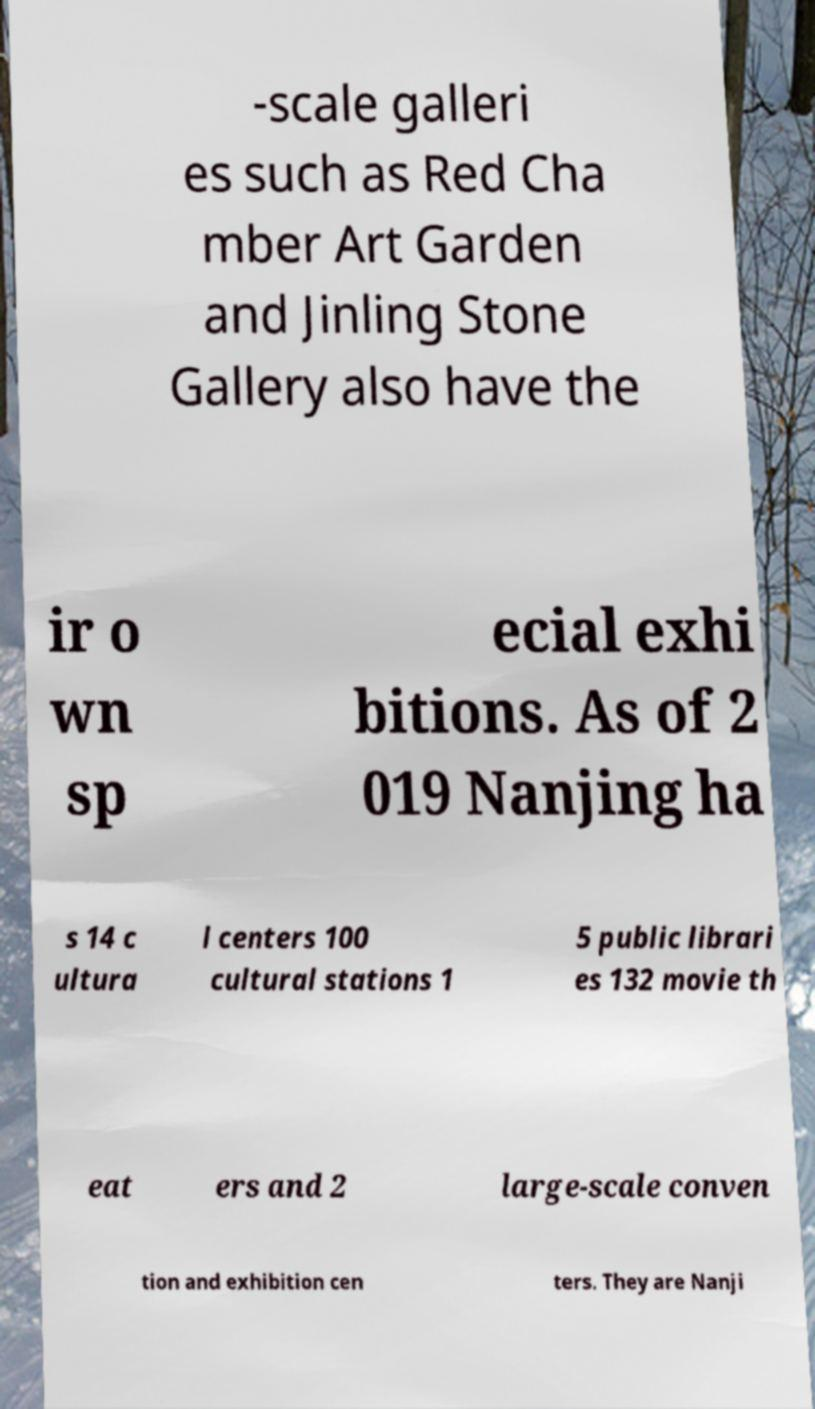There's text embedded in this image that I need extracted. Can you transcribe it verbatim? -scale galleri es such as Red Cha mber Art Garden and Jinling Stone Gallery also have the ir o wn sp ecial exhi bitions. As of 2 019 Nanjing ha s 14 c ultura l centers 100 cultural stations 1 5 public librari es 132 movie th eat ers and 2 large-scale conven tion and exhibition cen ters. They are Nanji 